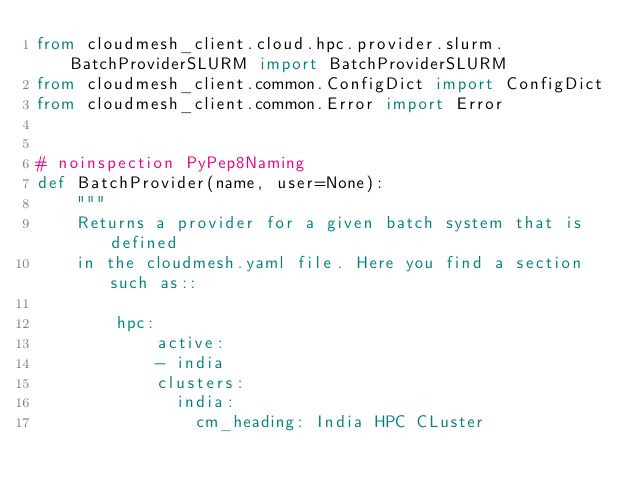Convert code to text. <code><loc_0><loc_0><loc_500><loc_500><_Python_>from cloudmesh_client.cloud.hpc.provider.slurm.BatchProviderSLURM import BatchProviderSLURM
from cloudmesh_client.common.ConfigDict import ConfigDict
from cloudmesh_client.common.Error import Error


# noinspection PyPep8Naming
def BatchProvider(name, user=None):
    """
    Returns a provider for a given batch system that is defined
    in the cloudmesh.yaml file. Here you find a section such as::

        hpc:
            active:
            - india
            clusters:
              india:
                cm_heading: India HPC CLuster</code> 